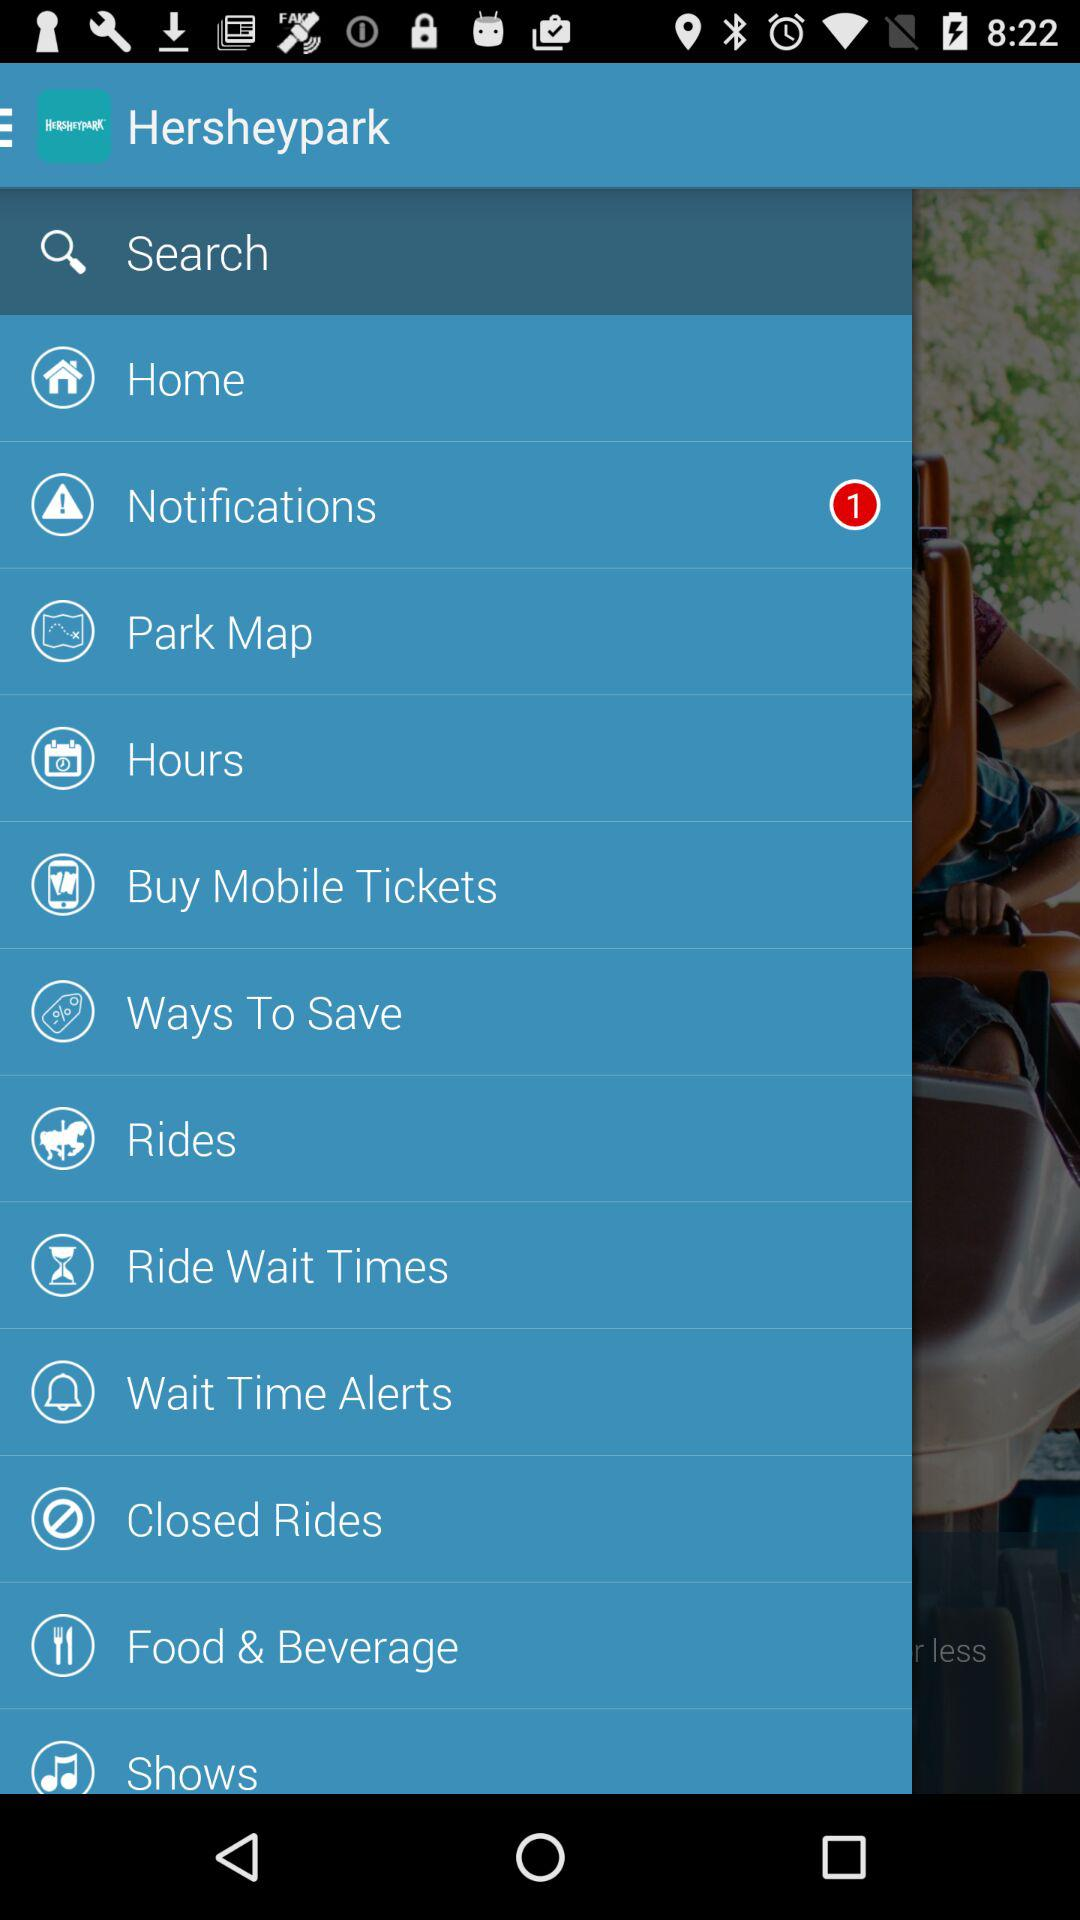What is the name of the application? The name of the application is "Hersheypark". 